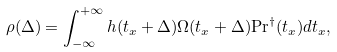Convert formula to latex. <formula><loc_0><loc_0><loc_500><loc_500>\rho ( \Delta ) = \int _ { - \infty } ^ { + \infty } h ( t _ { x } + \Delta ) \Omega ( t _ { x } + \Delta ) { \Pr } ^ { \dagger } ( t _ { x } ) d t _ { x } ,</formula> 